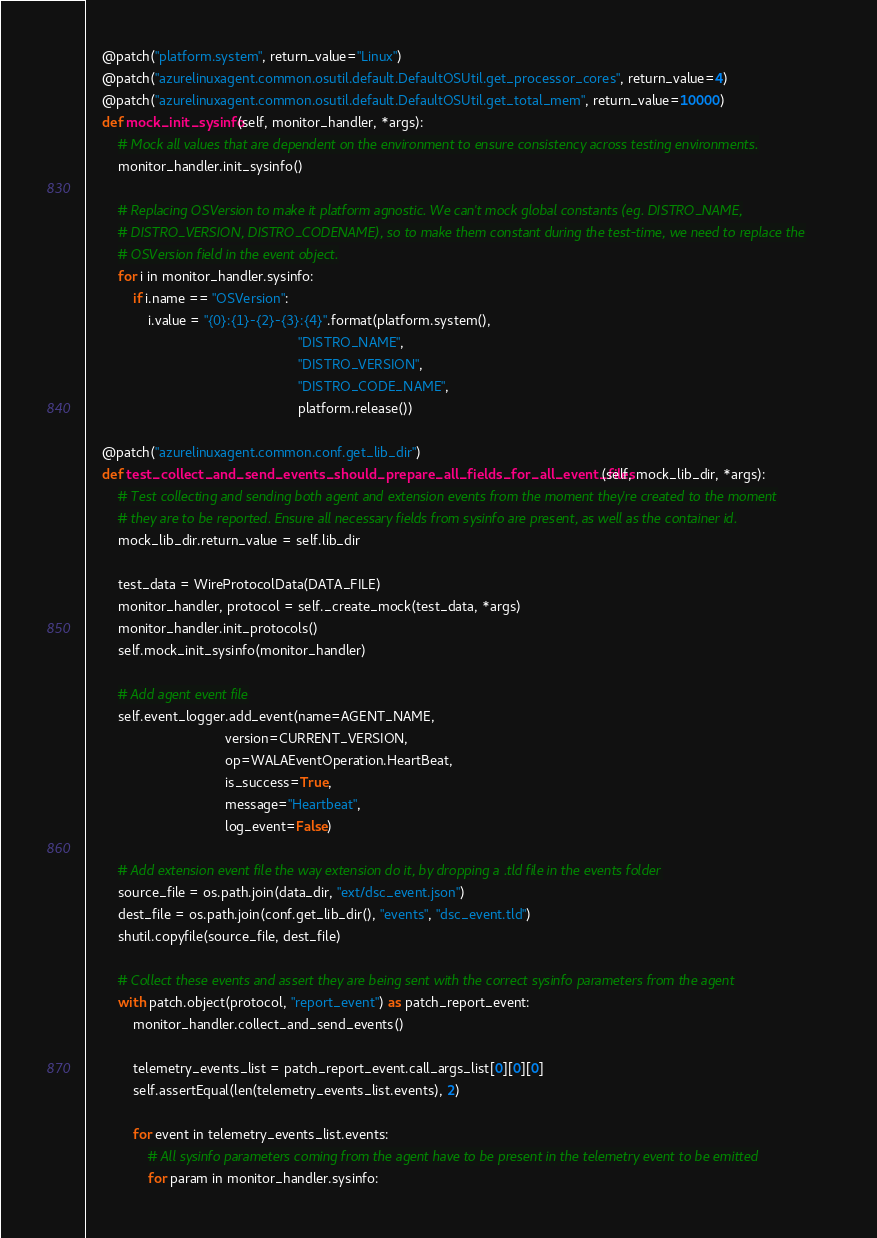Convert code to text. <code><loc_0><loc_0><loc_500><loc_500><_Python_>    @patch("platform.system", return_value="Linux")
    @patch("azurelinuxagent.common.osutil.default.DefaultOSUtil.get_processor_cores", return_value=4)
    @patch("azurelinuxagent.common.osutil.default.DefaultOSUtil.get_total_mem", return_value=10000)
    def mock_init_sysinfo(self, monitor_handler, *args):
        # Mock all values that are dependent on the environment to ensure consistency across testing environments.
        monitor_handler.init_sysinfo()

        # Replacing OSVersion to make it platform agnostic. We can't mock global constants (eg. DISTRO_NAME,
        # DISTRO_VERSION, DISTRO_CODENAME), so to make them constant during the test-time, we need to replace the
        # OSVersion field in the event object.
        for i in monitor_handler.sysinfo:
            if i.name == "OSVersion":
                i.value = "{0}:{1}-{2}-{3}:{4}".format(platform.system(),
                                                       "DISTRO_NAME",
                                                       "DISTRO_VERSION",
                                                       "DISTRO_CODE_NAME",
                                                       platform.release())

    @patch("azurelinuxagent.common.conf.get_lib_dir")
    def test_collect_and_send_events_should_prepare_all_fields_for_all_event_files(self, mock_lib_dir, *args):
        # Test collecting and sending both agent and extension events from the moment they're created to the moment
        # they are to be reported. Ensure all necessary fields from sysinfo are present, as well as the container id.
        mock_lib_dir.return_value = self.lib_dir

        test_data = WireProtocolData(DATA_FILE)
        monitor_handler, protocol = self._create_mock(test_data, *args)
        monitor_handler.init_protocols()
        self.mock_init_sysinfo(monitor_handler)

        # Add agent event file
        self.event_logger.add_event(name=AGENT_NAME,
                                    version=CURRENT_VERSION,
                                    op=WALAEventOperation.HeartBeat,
                                    is_success=True,
                                    message="Heartbeat",
                                    log_event=False)

        # Add extension event file the way extension do it, by dropping a .tld file in the events folder
        source_file = os.path.join(data_dir, "ext/dsc_event.json")
        dest_file = os.path.join(conf.get_lib_dir(), "events", "dsc_event.tld")
        shutil.copyfile(source_file, dest_file)

        # Collect these events and assert they are being sent with the correct sysinfo parameters from the agent
        with patch.object(protocol, "report_event") as patch_report_event:
            monitor_handler.collect_and_send_events()

            telemetry_events_list = patch_report_event.call_args_list[0][0][0]
            self.assertEqual(len(telemetry_events_list.events), 2)

            for event in telemetry_events_list.events:
                # All sysinfo parameters coming from the agent have to be present in the telemetry event to be emitted
                for param in monitor_handler.sysinfo:</code> 